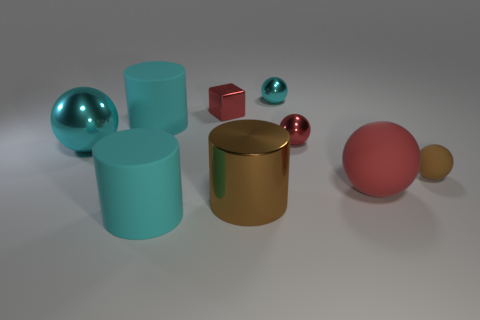Subtract all cyan matte cylinders. How many cylinders are left? 1 Add 1 big yellow matte cylinders. How many objects exist? 10 Subtract all brown cylinders. How many cylinders are left? 2 Subtract all cyan cylinders. How many green balls are left? 0 Subtract all brown blocks. Subtract all green spheres. How many blocks are left? 1 Subtract all large red rubber things. Subtract all brown balls. How many objects are left? 7 Add 6 metal cylinders. How many metal cylinders are left? 7 Add 8 cyan rubber things. How many cyan rubber things exist? 10 Subtract 0 purple balls. How many objects are left? 9 Subtract all cubes. How many objects are left? 8 